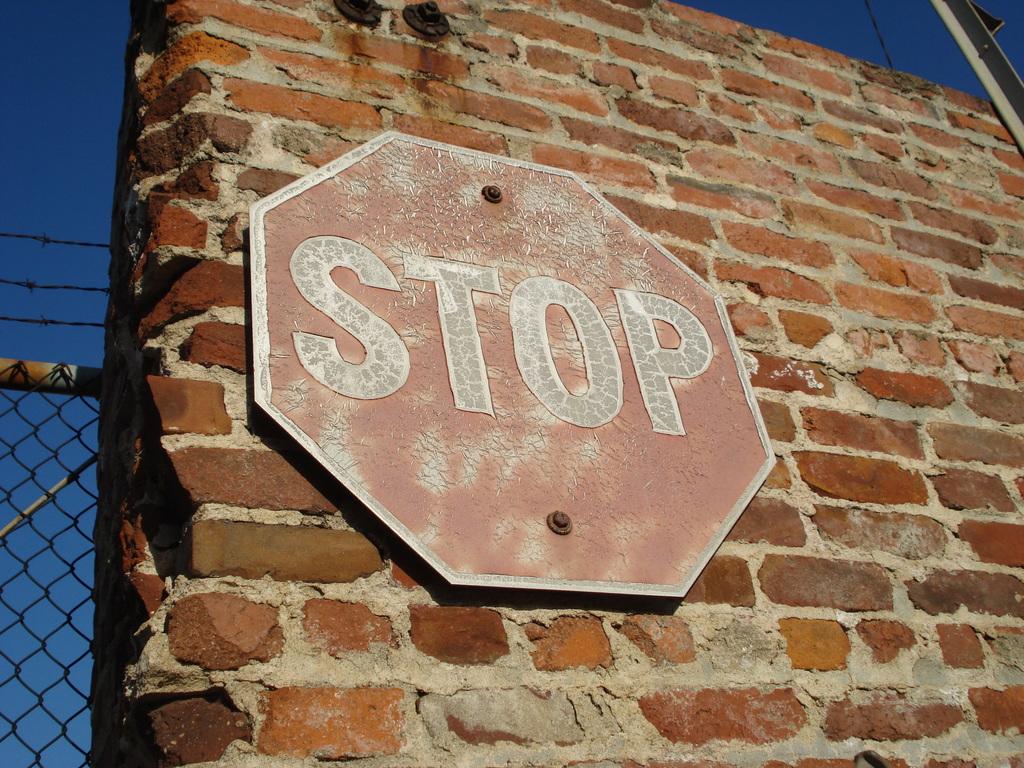What does the sign say?
Offer a very short reply. Stop. 